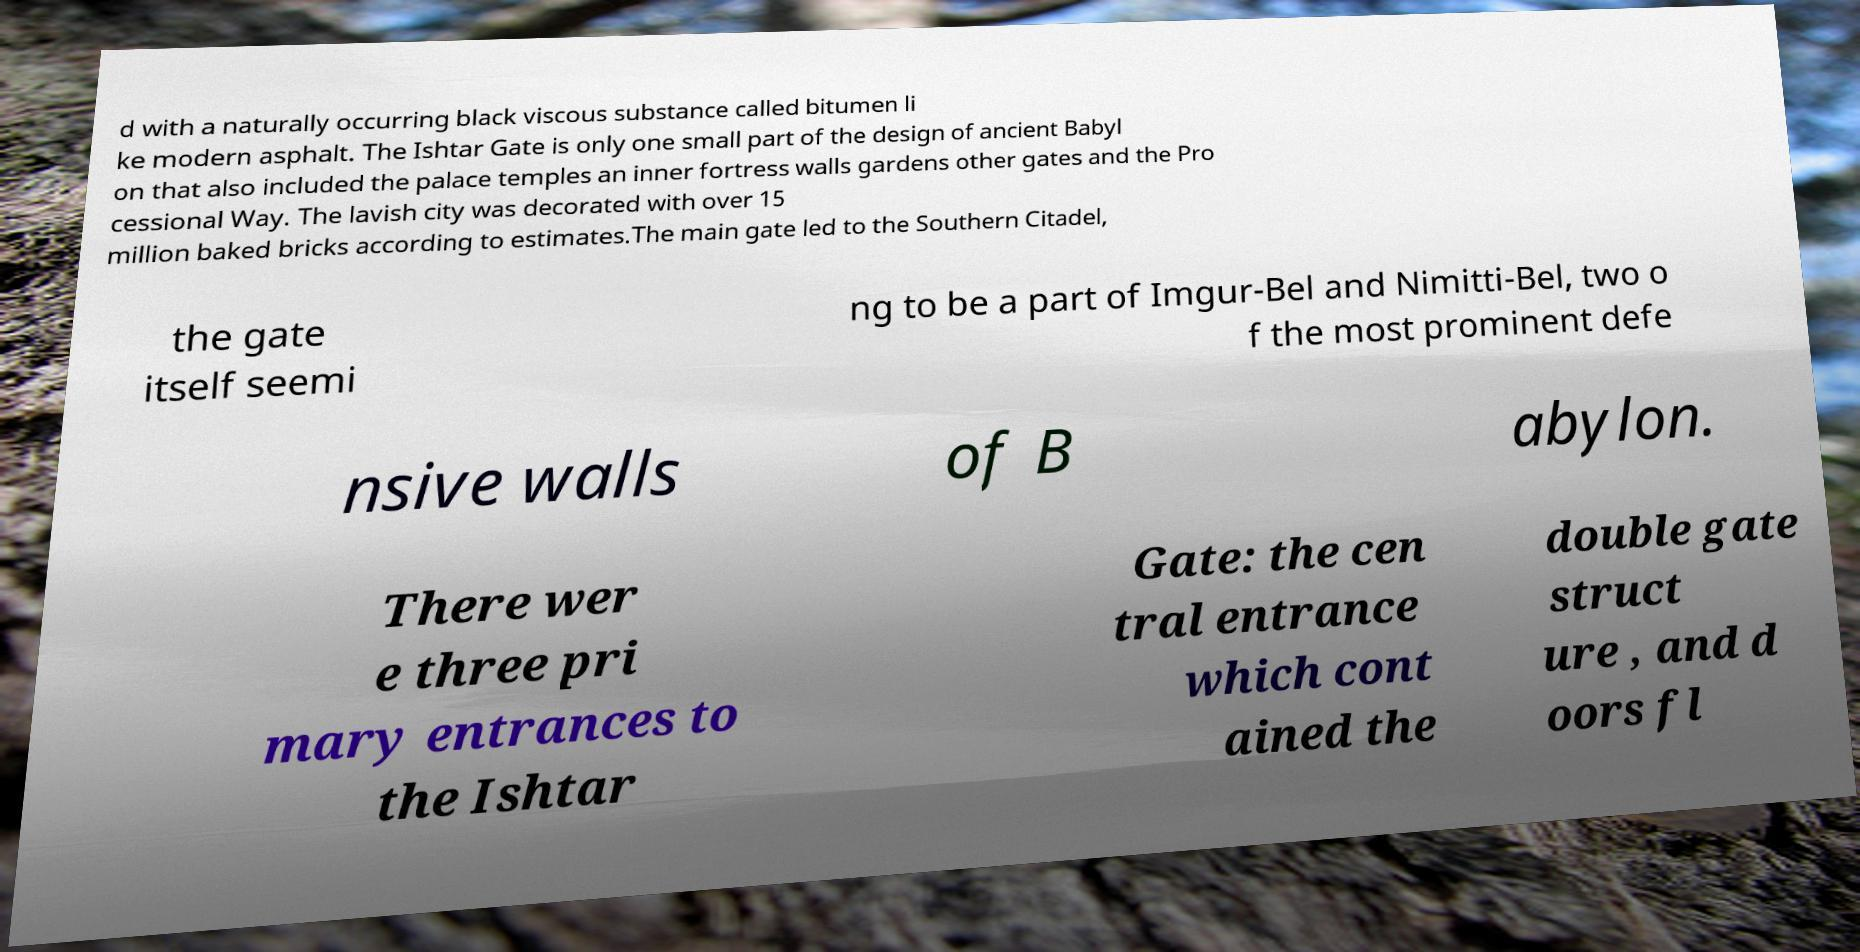Could you extract and type out the text from this image? d with a naturally occurring black viscous substance called bitumen li ke modern asphalt. The Ishtar Gate is only one small part of the design of ancient Babyl on that also included the palace temples an inner fortress walls gardens other gates and the Pro cessional Way. The lavish city was decorated with over 15 million baked bricks according to estimates.The main gate led to the Southern Citadel, the gate itself seemi ng to be a part of Imgur-Bel and Nimitti-Bel, two o f the most prominent defe nsive walls of B abylon. There wer e three pri mary entrances to the Ishtar Gate: the cen tral entrance which cont ained the double gate struct ure , and d oors fl 